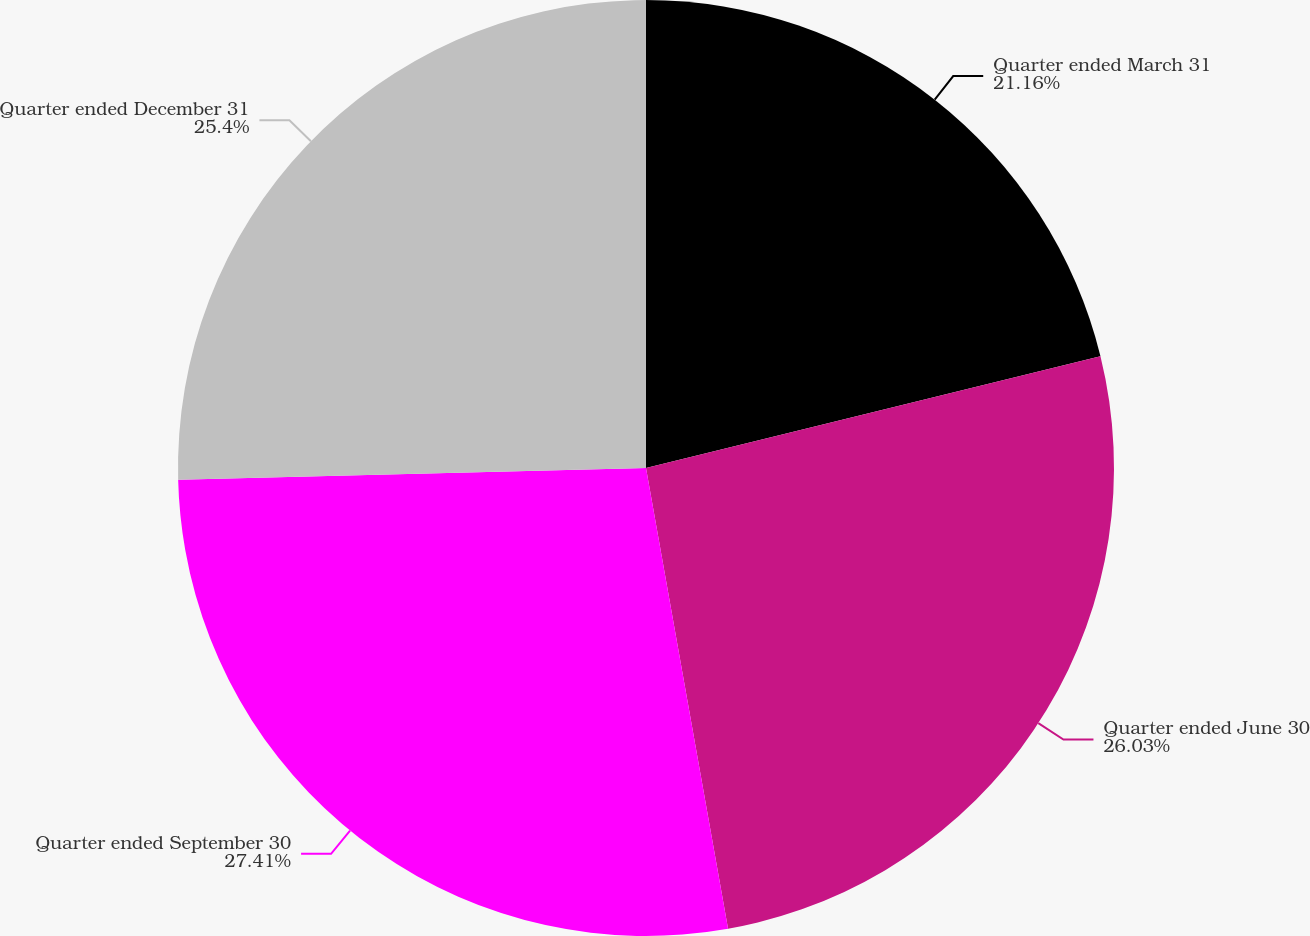Convert chart to OTSL. <chart><loc_0><loc_0><loc_500><loc_500><pie_chart><fcel>Quarter ended March 31<fcel>Quarter ended June 30<fcel>Quarter ended September 30<fcel>Quarter ended December 31<nl><fcel>21.16%<fcel>26.03%<fcel>27.4%<fcel>25.4%<nl></chart> 